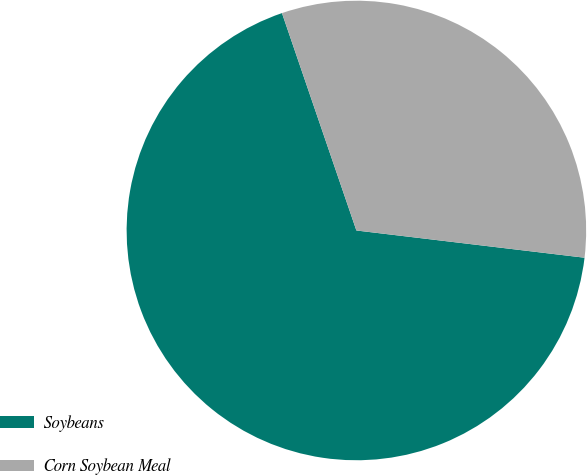<chart> <loc_0><loc_0><loc_500><loc_500><pie_chart><fcel>Soybeans<fcel>Corn Soybean Meal<nl><fcel>67.86%<fcel>32.14%<nl></chart> 